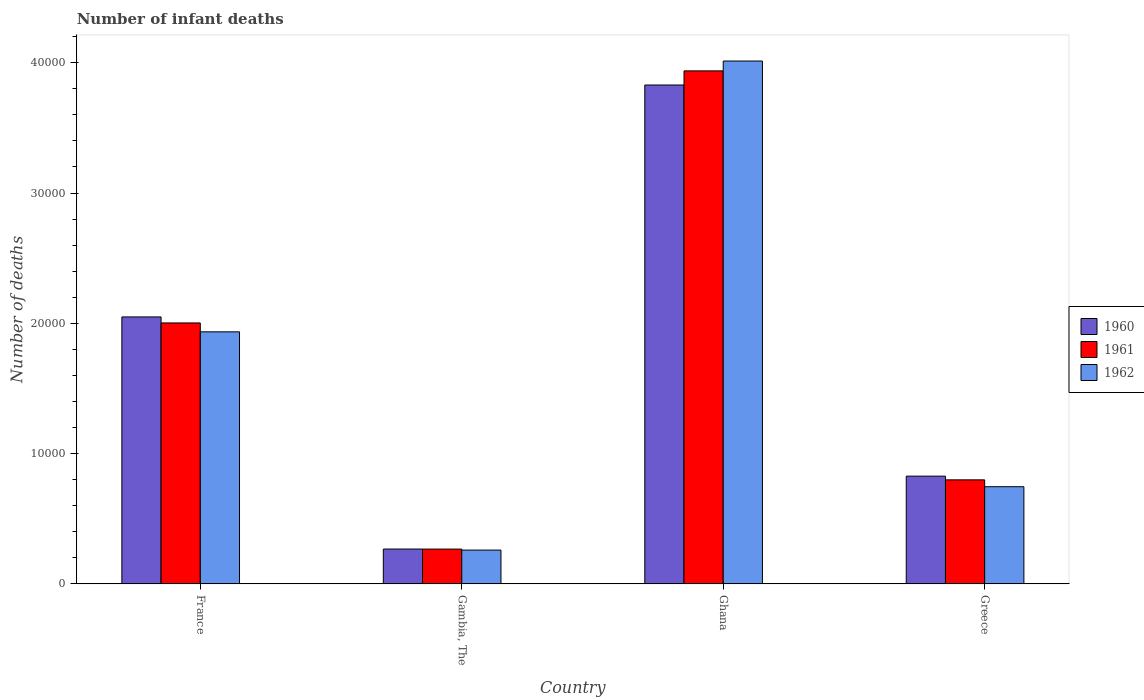How many different coloured bars are there?
Your answer should be very brief. 3. How many groups of bars are there?
Make the answer very short. 4. Are the number of bars per tick equal to the number of legend labels?
Ensure brevity in your answer.  Yes. How many bars are there on the 2nd tick from the right?
Offer a very short reply. 3. What is the label of the 1st group of bars from the left?
Provide a succinct answer. France. What is the number of infant deaths in 1961 in Ghana?
Provide a succinct answer. 3.94e+04. Across all countries, what is the maximum number of infant deaths in 1962?
Provide a short and direct response. 4.01e+04. Across all countries, what is the minimum number of infant deaths in 1962?
Make the answer very short. 2593. In which country was the number of infant deaths in 1960 minimum?
Offer a very short reply. Gambia, The. What is the total number of infant deaths in 1962 in the graph?
Make the answer very short. 6.95e+04. What is the difference between the number of infant deaths in 1961 in Gambia, The and that in Ghana?
Offer a very short reply. -3.67e+04. What is the difference between the number of infant deaths in 1960 in Greece and the number of infant deaths in 1962 in Gambia, The?
Provide a succinct answer. 5676. What is the average number of infant deaths in 1961 per country?
Your response must be concise. 1.75e+04. What is the difference between the number of infant deaths of/in 1960 and number of infant deaths of/in 1962 in France?
Give a very brief answer. 1145. What is the ratio of the number of infant deaths in 1961 in Gambia, The to that in Ghana?
Offer a very short reply. 0.07. Is the number of infant deaths in 1962 in Gambia, The less than that in Ghana?
Keep it short and to the point. Yes. Is the difference between the number of infant deaths in 1960 in Gambia, The and Ghana greater than the difference between the number of infant deaths in 1962 in Gambia, The and Ghana?
Give a very brief answer. Yes. What is the difference between the highest and the second highest number of infant deaths in 1960?
Offer a very short reply. 1.22e+04. What is the difference between the highest and the lowest number of infant deaths in 1961?
Keep it short and to the point. 3.67e+04. What does the 3rd bar from the left in Ghana represents?
Make the answer very short. 1962. What does the 1st bar from the right in Greece represents?
Ensure brevity in your answer.  1962. Is it the case that in every country, the sum of the number of infant deaths in 1960 and number of infant deaths in 1962 is greater than the number of infant deaths in 1961?
Offer a very short reply. Yes. Are all the bars in the graph horizontal?
Keep it short and to the point. No. How many countries are there in the graph?
Provide a succinct answer. 4. Are the values on the major ticks of Y-axis written in scientific E-notation?
Offer a terse response. No. Does the graph contain grids?
Ensure brevity in your answer.  No. What is the title of the graph?
Your answer should be very brief. Number of infant deaths. Does "1983" appear as one of the legend labels in the graph?
Provide a succinct answer. No. What is the label or title of the Y-axis?
Give a very brief answer. Number of deaths. What is the Number of deaths in 1960 in France?
Keep it short and to the point. 2.05e+04. What is the Number of deaths of 1961 in France?
Provide a short and direct response. 2.00e+04. What is the Number of deaths in 1962 in France?
Keep it short and to the point. 1.93e+04. What is the Number of deaths in 1960 in Gambia, The?
Offer a terse response. 2673. What is the Number of deaths in 1961 in Gambia, The?
Provide a short and direct response. 2669. What is the Number of deaths of 1962 in Gambia, The?
Your answer should be very brief. 2593. What is the Number of deaths of 1960 in Ghana?
Make the answer very short. 3.83e+04. What is the Number of deaths in 1961 in Ghana?
Keep it short and to the point. 3.94e+04. What is the Number of deaths of 1962 in Ghana?
Provide a short and direct response. 4.01e+04. What is the Number of deaths in 1960 in Greece?
Your answer should be very brief. 8269. What is the Number of deaths in 1961 in Greece?
Offer a terse response. 7984. What is the Number of deaths of 1962 in Greece?
Provide a short and direct response. 7457. Across all countries, what is the maximum Number of deaths of 1960?
Offer a terse response. 3.83e+04. Across all countries, what is the maximum Number of deaths of 1961?
Offer a terse response. 3.94e+04. Across all countries, what is the maximum Number of deaths of 1962?
Provide a succinct answer. 4.01e+04. Across all countries, what is the minimum Number of deaths of 1960?
Give a very brief answer. 2673. Across all countries, what is the minimum Number of deaths in 1961?
Offer a very short reply. 2669. Across all countries, what is the minimum Number of deaths of 1962?
Offer a very short reply. 2593. What is the total Number of deaths of 1960 in the graph?
Ensure brevity in your answer.  6.97e+04. What is the total Number of deaths of 1961 in the graph?
Give a very brief answer. 7.01e+04. What is the total Number of deaths in 1962 in the graph?
Offer a terse response. 6.95e+04. What is the difference between the Number of deaths of 1960 in France and that in Gambia, The?
Your answer should be very brief. 1.78e+04. What is the difference between the Number of deaths of 1961 in France and that in Gambia, The?
Provide a succinct answer. 1.74e+04. What is the difference between the Number of deaths of 1962 in France and that in Gambia, The?
Offer a terse response. 1.68e+04. What is the difference between the Number of deaths in 1960 in France and that in Ghana?
Your answer should be very brief. -1.78e+04. What is the difference between the Number of deaths in 1961 in France and that in Ghana?
Provide a succinct answer. -1.93e+04. What is the difference between the Number of deaths of 1962 in France and that in Ghana?
Your answer should be compact. -2.08e+04. What is the difference between the Number of deaths of 1960 in France and that in Greece?
Ensure brevity in your answer.  1.22e+04. What is the difference between the Number of deaths in 1961 in France and that in Greece?
Give a very brief answer. 1.20e+04. What is the difference between the Number of deaths of 1962 in France and that in Greece?
Provide a succinct answer. 1.19e+04. What is the difference between the Number of deaths in 1960 in Gambia, The and that in Ghana?
Make the answer very short. -3.56e+04. What is the difference between the Number of deaths of 1961 in Gambia, The and that in Ghana?
Offer a very short reply. -3.67e+04. What is the difference between the Number of deaths of 1962 in Gambia, The and that in Ghana?
Keep it short and to the point. -3.75e+04. What is the difference between the Number of deaths in 1960 in Gambia, The and that in Greece?
Your response must be concise. -5596. What is the difference between the Number of deaths of 1961 in Gambia, The and that in Greece?
Give a very brief answer. -5315. What is the difference between the Number of deaths in 1962 in Gambia, The and that in Greece?
Provide a succinct answer. -4864. What is the difference between the Number of deaths of 1960 in Ghana and that in Greece?
Your response must be concise. 3.00e+04. What is the difference between the Number of deaths in 1961 in Ghana and that in Greece?
Offer a very short reply. 3.14e+04. What is the difference between the Number of deaths in 1962 in Ghana and that in Greece?
Offer a terse response. 3.27e+04. What is the difference between the Number of deaths of 1960 in France and the Number of deaths of 1961 in Gambia, The?
Your response must be concise. 1.78e+04. What is the difference between the Number of deaths in 1960 in France and the Number of deaths in 1962 in Gambia, The?
Offer a terse response. 1.79e+04. What is the difference between the Number of deaths of 1961 in France and the Number of deaths of 1962 in Gambia, The?
Your response must be concise. 1.74e+04. What is the difference between the Number of deaths of 1960 in France and the Number of deaths of 1961 in Ghana?
Offer a terse response. -1.89e+04. What is the difference between the Number of deaths in 1960 in France and the Number of deaths in 1962 in Ghana?
Ensure brevity in your answer.  -1.96e+04. What is the difference between the Number of deaths in 1961 in France and the Number of deaths in 1962 in Ghana?
Your response must be concise. -2.01e+04. What is the difference between the Number of deaths of 1960 in France and the Number of deaths of 1961 in Greece?
Keep it short and to the point. 1.25e+04. What is the difference between the Number of deaths in 1960 in France and the Number of deaths in 1962 in Greece?
Keep it short and to the point. 1.30e+04. What is the difference between the Number of deaths in 1961 in France and the Number of deaths in 1962 in Greece?
Offer a terse response. 1.26e+04. What is the difference between the Number of deaths in 1960 in Gambia, The and the Number of deaths in 1961 in Ghana?
Your response must be concise. -3.67e+04. What is the difference between the Number of deaths in 1960 in Gambia, The and the Number of deaths in 1962 in Ghana?
Provide a succinct answer. -3.75e+04. What is the difference between the Number of deaths of 1961 in Gambia, The and the Number of deaths of 1962 in Ghana?
Your answer should be compact. -3.75e+04. What is the difference between the Number of deaths in 1960 in Gambia, The and the Number of deaths in 1961 in Greece?
Offer a very short reply. -5311. What is the difference between the Number of deaths in 1960 in Gambia, The and the Number of deaths in 1962 in Greece?
Make the answer very short. -4784. What is the difference between the Number of deaths in 1961 in Gambia, The and the Number of deaths in 1962 in Greece?
Give a very brief answer. -4788. What is the difference between the Number of deaths in 1960 in Ghana and the Number of deaths in 1961 in Greece?
Offer a terse response. 3.03e+04. What is the difference between the Number of deaths in 1960 in Ghana and the Number of deaths in 1962 in Greece?
Provide a succinct answer. 3.08e+04. What is the difference between the Number of deaths in 1961 in Ghana and the Number of deaths in 1962 in Greece?
Offer a terse response. 3.19e+04. What is the average Number of deaths in 1960 per country?
Provide a succinct answer. 1.74e+04. What is the average Number of deaths in 1961 per country?
Your answer should be very brief. 1.75e+04. What is the average Number of deaths in 1962 per country?
Keep it short and to the point. 1.74e+04. What is the difference between the Number of deaths of 1960 and Number of deaths of 1961 in France?
Make the answer very short. 462. What is the difference between the Number of deaths of 1960 and Number of deaths of 1962 in France?
Your answer should be compact. 1145. What is the difference between the Number of deaths of 1961 and Number of deaths of 1962 in France?
Offer a very short reply. 683. What is the difference between the Number of deaths of 1960 and Number of deaths of 1962 in Gambia, The?
Offer a terse response. 80. What is the difference between the Number of deaths of 1961 and Number of deaths of 1962 in Gambia, The?
Provide a succinct answer. 76. What is the difference between the Number of deaths of 1960 and Number of deaths of 1961 in Ghana?
Your response must be concise. -1084. What is the difference between the Number of deaths in 1960 and Number of deaths in 1962 in Ghana?
Provide a short and direct response. -1841. What is the difference between the Number of deaths in 1961 and Number of deaths in 1962 in Ghana?
Provide a succinct answer. -757. What is the difference between the Number of deaths in 1960 and Number of deaths in 1961 in Greece?
Offer a very short reply. 285. What is the difference between the Number of deaths of 1960 and Number of deaths of 1962 in Greece?
Offer a very short reply. 812. What is the difference between the Number of deaths in 1961 and Number of deaths in 1962 in Greece?
Your answer should be compact. 527. What is the ratio of the Number of deaths in 1960 in France to that in Gambia, The?
Provide a succinct answer. 7.67. What is the ratio of the Number of deaths of 1961 in France to that in Gambia, The?
Give a very brief answer. 7.5. What is the ratio of the Number of deaths in 1962 in France to that in Gambia, The?
Your response must be concise. 7.46. What is the ratio of the Number of deaths of 1960 in France to that in Ghana?
Your answer should be very brief. 0.54. What is the ratio of the Number of deaths in 1961 in France to that in Ghana?
Provide a short and direct response. 0.51. What is the ratio of the Number of deaths of 1962 in France to that in Ghana?
Ensure brevity in your answer.  0.48. What is the ratio of the Number of deaths in 1960 in France to that in Greece?
Provide a succinct answer. 2.48. What is the ratio of the Number of deaths of 1961 in France to that in Greece?
Ensure brevity in your answer.  2.51. What is the ratio of the Number of deaths in 1962 in France to that in Greece?
Make the answer very short. 2.59. What is the ratio of the Number of deaths of 1960 in Gambia, The to that in Ghana?
Ensure brevity in your answer.  0.07. What is the ratio of the Number of deaths of 1961 in Gambia, The to that in Ghana?
Keep it short and to the point. 0.07. What is the ratio of the Number of deaths in 1962 in Gambia, The to that in Ghana?
Ensure brevity in your answer.  0.06. What is the ratio of the Number of deaths of 1960 in Gambia, The to that in Greece?
Your response must be concise. 0.32. What is the ratio of the Number of deaths in 1961 in Gambia, The to that in Greece?
Provide a succinct answer. 0.33. What is the ratio of the Number of deaths of 1962 in Gambia, The to that in Greece?
Keep it short and to the point. 0.35. What is the ratio of the Number of deaths of 1960 in Ghana to that in Greece?
Make the answer very short. 4.63. What is the ratio of the Number of deaths in 1961 in Ghana to that in Greece?
Your answer should be very brief. 4.93. What is the ratio of the Number of deaths of 1962 in Ghana to that in Greece?
Offer a very short reply. 5.38. What is the difference between the highest and the second highest Number of deaths of 1960?
Ensure brevity in your answer.  1.78e+04. What is the difference between the highest and the second highest Number of deaths of 1961?
Your response must be concise. 1.93e+04. What is the difference between the highest and the second highest Number of deaths in 1962?
Provide a succinct answer. 2.08e+04. What is the difference between the highest and the lowest Number of deaths of 1960?
Give a very brief answer. 3.56e+04. What is the difference between the highest and the lowest Number of deaths of 1961?
Ensure brevity in your answer.  3.67e+04. What is the difference between the highest and the lowest Number of deaths of 1962?
Provide a short and direct response. 3.75e+04. 